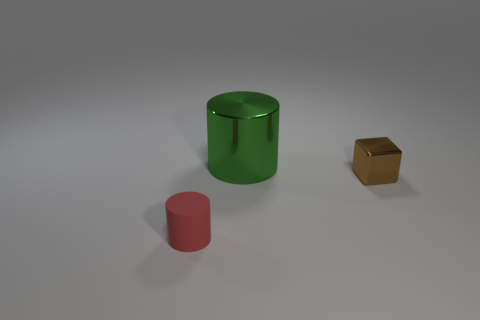Add 3 matte cylinders. How many objects exist? 6 Subtract all cylinders. How many objects are left? 1 Subtract 0 purple blocks. How many objects are left? 3 Subtract all cyan cylinders. Subtract all large green metal things. How many objects are left? 2 Add 1 big cylinders. How many big cylinders are left? 2 Add 2 brown metallic blocks. How many brown metallic blocks exist? 3 